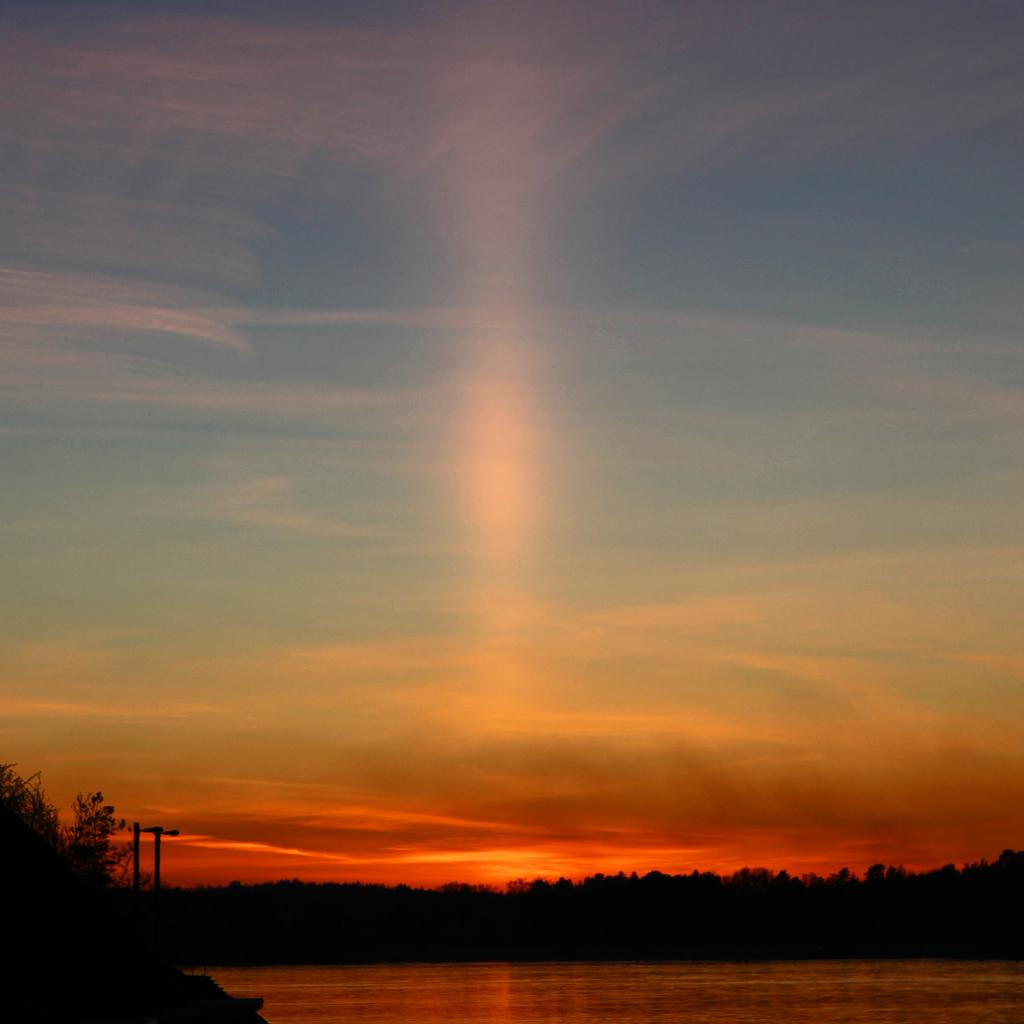What is the primary element visible in the image? There is water in the image. What other natural elements can be seen in the image? There are trees in the image. Are there any man-made structures visible in the image? Yes, there are poles in the image. What can be seen in the background of the image? The sky is visible in the background of the image, and clouds are present in the sky. What type of property is being sold in the image? There is no indication of any property being sold in the image. What time of day is it in the image, considering the presence of clouds? The presence of clouds does not indicate a specific time of day in the image. 